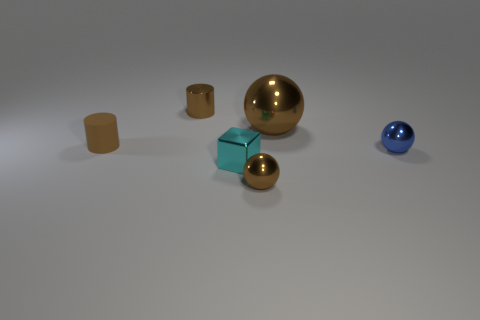Subtract all brown metallic balls. How many balls are left? 1 Subtract all cylinders. How many objects are left? 4 Add 2 blue rubber objects. How many blue rubber objects exist? 2 Add 3 brown objects. How many objects exist? 9 Subtract all brown balls. How many balls are left? 1 Subtract 2 brown cylinders. How many objects are left? 4 Subtract 3 balls. How many balls are left? 0 Subtract all gray balls. Subtract all brown blocks. How many balls are left? 3 Subtract all blue cubes. How many brown balls are left? 2 Subtract all small cyan metal blocks. Subtract all rubber cylinders. How many objects are left? 4 